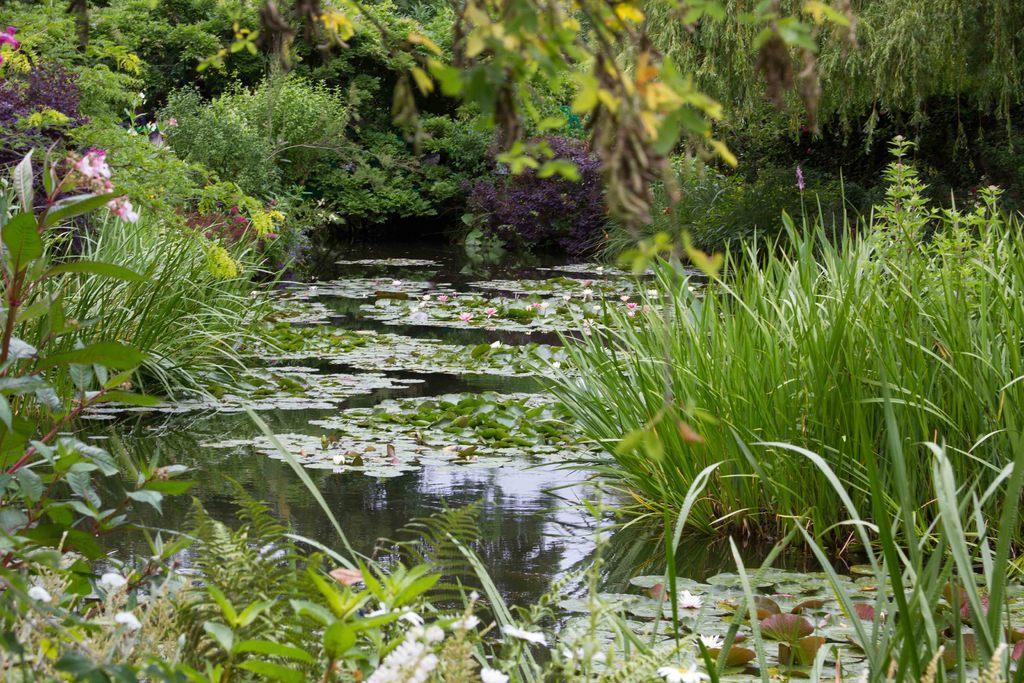Can you describe this image briefly? In this image there is water and we can see leaves on the water. At the bottom there is grass and plants. In the background there are trees. We can see flowers. 